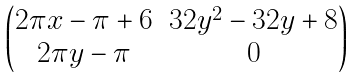Convert formula to latex. <formula><loc_0><loc_0><loc_500><loc_500>\begin{pmatrix} 2 \pi x - \pi + 6 & 3 2 y ^ { 2 } - 3 2 y + 8 \\ 2 \pi y - \pi & 0 \end{pmatrix}</formula> 